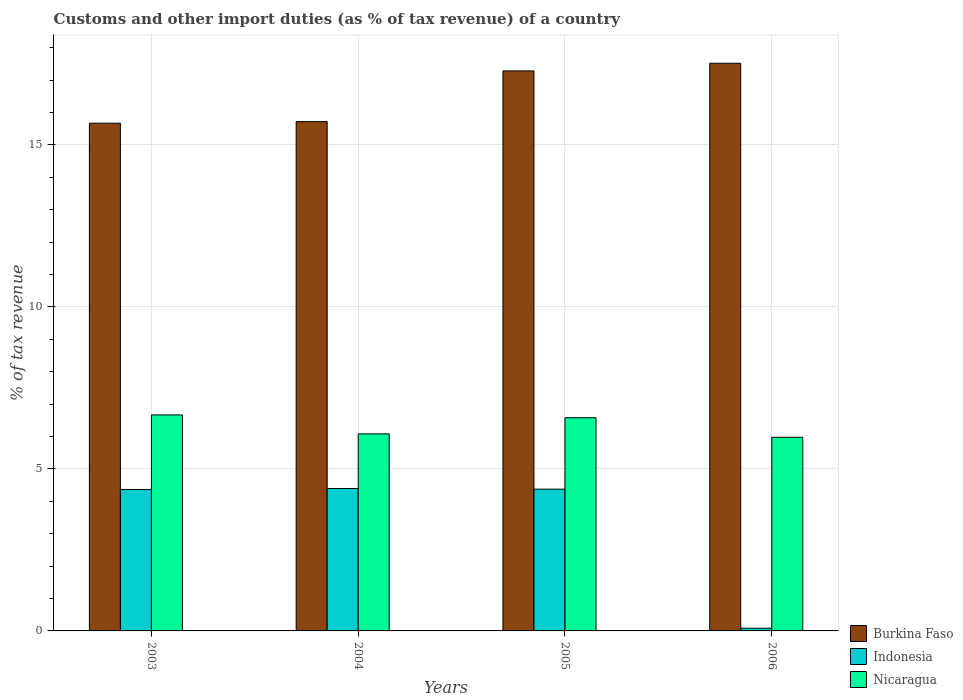How many groups of bars are there?
Offer a terse response. 4. Are the number of bars per tick equal to the number of legend labels?
Your response must be concise. Yes. Are the number of bars on each tick of the X-axis equal?
Provide a short and direct response. Yes. How many bars are there on the 2nd tick from the left?
Provide a short and direct response. 3. What is the label of the 3rd group of bars from the left?
Ensure brevity in your answer.  2005. What is the percentage of tax revenue from customs in Burkina Faso in 2004?
Give a very brief answer. 15.72. Across all years, what is the maximum percentage of tax revenue from customs in Nicaragua?
Provide a short and direct response. 6.67. Across all years, what is the minimum percentage of tax revenue from customs in Nicaragua?
Your response must be concise. 5.98. In which year was the percentage of tax revenue from customs in Indonesia minimum?
Provide a succinct answer. 2006. What is the total percentage of tax revenue from customs in Nicaragua in the graph?
Keep it short and to the point. 25.31. What is the difference between the percentage of tax revenue from customs in Nicaragua in 2005 and that in 2006?
Make the answer very short. 0.6. What is the difference between the percentage of tax revenue from customs in Nicaragua in 2003 and the percentage of tax revenue from customs in Burkina Faso in 2004?
Provide a succinct answer. -9.05. What is the average percentage of tax revenue from customs in Nicaragua per year?
Your answer should be very brief. 6.33. In the year 2006, what is the difference between the percentage of tax revenue from customs in Nicaragua and percentage of tax revenue from customs in Indonesia?
Make the answer very short. 5.89. What is the ratio of the percentage of tax revenue from customs in Burkina Faso in 2004 to that in 2006?
Your answer should be compact. 0.9. Is the percentage of tax revenue from customs in Indonesia in 2005 less than that in 2006?
Provide a succinct answer. No. What is the difference between the highest and the second highest percentage of tax revenue from customs in Nicaragua?
Provide a succinct answer. 0.09. What is the difference between the highest and the lowest percentage of tax revenue from customs in Nicaragua?
Your answer should be very brief. 0.69. Is the sum of the percentage of tax revenue from customs in Indonesia in 2003 and 2005 greater than the maximum percentage of tax revenue from customs in Nicaragua across all years?
Give a very brief answer. Yes. What does the 3rd bar from the left in 2004 represents?
Offer a terse response. Nicaragua. What does the 2nd bar from the right in 2004 represents?
Ensure brevity in your answer.  Indonesia. Is it the case that in every year, the sum of the percentage of tax revenue from customs in Nicaragua and percentage of tax revenue from customs in Burkina Faso is greater than the percentage of tax revenue from customs in Indonesia?
Ensure brevity in your answer.  Yes. How many bars are there?
Provide a succinct answer. 12. Are all the bars in the graph horizontal?
Keep it short and to the point. No. How many years are there in the graph?
Offer a very short reply. 4. What is the difference between two consecutive major ticks on the Y-axis?
Provide a short and direct response. 5. Does the graph contain any zero values?
Provide a short and direct response. No. Does the graph contain grids?
Give a very brief answer. Yes. Where does the legend appear in the graph?
Your answer should be compact. Bottom right. How many legend labels are there?
Ensure brevity in your answer.  3. What is the title of the graph?
Your answer should be compact. Customs and other import duties (as % of tax revenue) of a country. Does "Curacao" appear as one of the legend labels in the graph?
Make the answer very short. No. What is the label or title of the Y-axis?
Provide a succinct answer. % of tax revenue. What is the % of tax revenue of Burkina Faso in 2003?
Make the answer very short. 15.67. What is the % of tax revenue of Indonesia in 2003?
Offer a very short reply. 4.36. What is the % of tax revenue of Nicaragua in 2003?
Your answer should be compact. 6.67. What is the % of tax revenue in Burkina Faso in 2004?
Your response must be concise. 15.72. What is the % of tax revenue in Indonesia in 2004?
Make the answer very short. 4.4. What is the % of tax revenue in Nicaragua in 2004?
Give a very brief answer. 6.08. What is the % of tax revenue of Burkina Faso in 2005?
Offer a terse response. 17.29. What is the % of tax revenue in Indonesia in 2005?
Offer a very short reply. 4.38. What is the % of tax revenue of Nicaragua in 2005?
Offer a very short reply. 6.58. What is the % of tax revenue in Burkina Faso in 2006?
Offer a terse response. 17.52. What is the % of tax revenue in Indonesia in 2006?
Your response must be concise. 0.08. What is the % of tax revenue in Nicaragua in 2006?
Provide a succinct answer. 5.98. Across all years, what is the maximum % of tax revenue of Burkina Faso?
Your answer should be compact. 17.52. Across all years, what is the maximum % of tax revenue in Indonesia?
Provide a succinct answer. 4.4. Across all years, what is the maximum % of tax revenue in Nicaragua?
Offer a very short reply. 6.67. Across all years, what is the minimum % of tax revenue in Burkina Faso?
Your answer should be compact. 15.67. Across all years, what is the minimum % of tax revenue in Indonesia?
Offer a very short reply. 0.08. Across all years, what is the minimum % of tax revenue of Nicaragua?
Offer a terse response. 5.98. What is the total % of tax revenue in Burkina Faso in the graph?
Offer a very short reply. 66.2. What is the total % of tax revenue of Indonesia in the graph?
Ensure brevity in your answer.  13.22. What is the total % of tax revenue in Nicaragua in the graph?
Provide a succinct answer. 25.31. What is the difference between the % of tax revenue in Burkina Faso in 2003 and that in 2004?
Ensure brevity in your answer.  -0.05. What is the difference between the % of tax revenue of Indonesia in 2003 and that in 2004?
Give a very brief answer. -0.03. What is the difference between the % of tax revenue of Nicaragua in 2003 and that in 2004?
Your response must be concise. 0.59. What is the difference between the % of tax revenue of Burkina Faso in 2003 and that in 2005?
Give a very brief answer. -1.61. What is the difference between the % of tax revenue in Indonesia in 2003 and that in 2005?
Offer a terse response. -0.01. What is the difference between the % of tax revenue in Nicaragua in 2003 and that in 2005?
Offer a terse response. 0.09. What is the difference between the % of tax revenue in Burkina Faso in 2003 and that in 2006?
Give a very brief answer. -1.85. What is the difference between the % of tax revenue in Indonesia in 2003 and that in 2006?
Offer a terse response. 4.28. What is the difference between the % of tax revenue of Nicaragua in 2003 and that in 2006?
Provide a short and direct response. 0.69. What is the difference between the % of tax revenue of Burkina Faso in 2004 and that in 2005?
Give a very brief answer. -1.57. What is the difference between the % of tax revenue in Indonesia in 2004 and that in 2005?
Provide a short and direct response. 0.02. What is the difference between the % of tax revenue in Nicaragua in 2004 and that in 2005?
Keep it short and to the point. -0.5. What is the difference between the % of tax revenue of Burkina Faso in 2004 and that in 2006?
Offer a very short reply. -1.8. What is the difference between the % of tax revenue of Indonesia in 2004 and that in 2006?
Your response must be concise. 4.31. What is the difference between the % of tax revenue of Nicaragua in 2004 and that in 2006?
Your answer should be very brief. 0.1. What is the difference between the % of tax revenue in Burkina Faso in 2005 and that in 2006?
Your answer should be very brief. -0.24. What is the difference between the % of tax revenue of Indonesia in 2005 and that in 2006?
Offer a very short reply. 4.29. What is the difference between the % of tax revenue in Nicaragua in 2005 and that in 2006?
Give a very brief answer. 0.6. What is the difference between the % of tax revenue of Burkina Faso in 2003 and the % of tax revenue of Indonesia in 2004?
Provide a succinct answer. 11.28. What is the difference between the % of tax revenue of Burkina Faso in 2003 and the % of tax revenue of Nicaragua in 2004?
Offer a terse response. 9.59. What is the difference between the % of tax revenue of Indonesia in 2003 and the % of tax revenue of Nicaragua in 2004?
Keep it short and to the point. -1.72. What is the difference between the % of tax revenue in Burkina Faso in 2003 and the % of tax revenue in Indonesia in 2005?
Offer a terse response. 11.3. What is the difference between the % of tax revenue of Burkina Faso in 2003 and the % of tax revenue of Nicaragua in 2005?
Ensure brevity in your answer.  9.09. What is the difference between the % of tax revenue in Indonesia in 2003 and the % of tax revenue in Nicaragua in 2005?
Provide a succinct answer. -2.22. What is the difference between the % of tax revenue in Burkina Faso in 2003 and the % of tax revenue in Indonesia in 2006?
Your answer should be compact. 15.59. What is the difference between the % of tax revenue in Burkina Faso in 2003 and the % of tax revenue in Nicaragua in 2006?
Your response must be concise. 9.7. What is the difference between the % of tax revenue of Indonesia in 2003 and the % of tax revenue of Nicaragua in 2006?
Your answer should be compact. -1.61. What is the difference between the % of tax revenue in Burkina Faso in 2004 and the % of tax revenue in Indonesia in 2005?
Provide a succinct answer. 11.35. What is the difference between the % of tax revenue of Burkina Faso in 2004 and the % of tax revenue of Nicaragua in 2005?
Your answer should be compact. 9.14. What is the difference between the % of tax revenue in Indonesia in 2004 and the % of tax revenue in Nicaragua in 2005?
Your answer should be compact. -2.19. What is the difference between the % of tax revenue of Burkina Faso in 2004 and the % of tax revenue of Indonesia in 2006?
Your answer should be very brief. 15.64. What is the difference between the % of tax revenue in Burkina Faso in 2004 and the % of tax revenue in Nicaragua in 2006?
Provide a succinct answer. 9.74. What is the difference between the % of tax revenue in Indonesia in 2004 and the % of tax revenue in Nicaragua in 2006?
Your answer should be compact. -1.58. What is the difference between the % of tax revenue in Burkina Faso in 2005 and the % of tax revenue in Indonesia in 2006?
Ensure brevity in your answer.  17.2. What is the difference between the % of tax revenue in Burkina Faso in 2005 and the % of tax revenue in Nicaragua in 2006?
Offer a terse response. 11.31. What is the difference between the % of tax revenue in Indonesia in 2005 and the % of tax revenue in Nicaragua in 2006?
Your answer should be very brief. -1.6. What is the average % of tax revenue of Burkina Faso per year?
Keep it short and to the point. 16.55. What is the average % of tax revenue in Indonesia per year?
Your answer should be very brief. 3.31. What is the average % of tax revenue of Nicaragua per year?
Your response must be concise. 6.33. In the year 2003, what is the difference between the % of tax revenue of Burkina Faso and % of tax revenue of Indonesia?
Your answer should be very brief. 11.31. In the year 2003, what is the difference between the % of tax revenue in Burkina Faso and % of tax revenue in Nicaragua?
Your answer should be compact. 9.01. In the year 2003, what is the difference between the % of tax revenue in Indonesia and % of tax revenue in Nicaragua?
Offer a terse response. -2.3. In the year 2004, what is the difference between the % of tax revenue of Burkina Faso and % of tax revenue of Indonesia?
Keep it short and to the point. 11.33. In the year 2004, what is the difference between the % of tax revenue of Burkina Faso and % of tax revenue of Nicaragua?
Provide a short and direct response. 9.64. In the year 2004, what is the difference between the % of tax revenue in Indonesia and % of tax revenue in Nicaragua?
Make the answer very short. -1.69. In the year 2005, what is the difference between the % of tax revenue of Burkina Faso and % of tax revenue of Indonesia?
Offer a terse response. 12.91. In the year 2005, what is the difference between the % of tax revenue of Burkina Faso and % of tax revenue of Nicaragua?
Provide a short and direct response. 10.71. In the year 2005, what is the difference between the % of tax revenue of Indonesia and % of tax revenue of Nicaragua?
Keep it short and to the point. -2.2. In the year 2006, what is the difference between the % of tax revenue in Burkina Faso and % of tax revenue in Indonesia?
Keep it short and to the point. 17.44. In the year 2006, what is the difference between the % of tax revenue of Burkina Faso and % of tax revenue of Nicaragua?
Make the answer very short. 11.55. In the year 2006, what is the difference between the % of tax revenue in Indonesia and % of tax revenue in Nicaragua?
Your response must be concise. -5.89. What is the ratio of the % of tax revenue in Burkina Faso in 2003 to that in 2004?
Offer a very short reply. 1. What is the ratio of the % of tax revenue in Nicaragua in 2003 to that in 2004?
Keep it short and to the point. 1.1. What is the ratio of the % of tax revenue of Burkina Faso in 2003 to that in 2005?
Offer a very short reply. 0.91. What is the ratio of the % of tax revenue of Indonesia in 2003 to that in 2005?
Make the answer very short. 1. What is the ratio of the % of tax revenue in Nicaragua in 2003 to that in 2005?
Ensure brevity in your answer.  1.01. What is the ratio of the % of tax revenue in Burkina Faso in 2003 to that in 2006?
Ensure brevity in your answer.  0.89. What is the ratio of the % of tax revenue of Indonesia in 2003 to that in 2006?
Your response must be concise. 51.81. What is the ratio of the % of tax revenue of Nicaragua in 2003 to that in 2006?
Provide a short and direct response. 1.12. What is the ratio of the % of tax revenue of Burkina Faso in 2004 to that in 2005?
Provide a succinct answer. 0.91. What is the ratio of the % of tax revenue of Indonesia in 2004 to that in 2005?
Your answer should be compact. 1. What is the ratio of the % of tax revenue in Nicaragua in 2004 to that in 2005?
Make the answer very short. 0.92. What is the ratio of the % of tax revenue in Burkina Faso in 2004 to that in 2006?
Offer a very short reply. 0.9. What is the ratio of the % of tax revenue in Indonesia in 2004 to that in 2006?
Ensure brevity in your answer.  52.18. What is the ratio of the % of tax revenue in Nicaragua in 2004 to that in 2006?
Your answer should be compact. 1.02. What is the ratio of the % of tax revenue of Burkina Faso in 2005 to that in 2006?
Make the answer very short. 0.99. What is the ratio of the % of tax revenue of Indonesia in 2005 to that in 2006?
Provide a succinct answer. 51.95. What is the ratio of the % of tax revenue in Nicaragua in 2005 to that in 2006?
Your answer should be compact. 1.1. What is the difference between the highest and the second highest % of tax revenue of Burkina Faso?
Offer a very short reply. 0.24. What is the difference between the highest and the second highest % of tax revenue in Indonesia?
Make the answer very short. 0.02. What is the difference between the highest and the second highest % of tax revenue of Nicaragua?
Offer a very short reply. 0.09. What is the difference between the highest and the lowest % of tax revenue in Burkina Faso?
Keep it short and to the point. 1.85. What is the difference between the highest and the lowest % of tax revenue of Indonesia?
Offer a terse response. 4.31. What is the difference between the highest and the lowest % of tax revenue of Nicaragua?
Offer a very short reply. 0.69. 